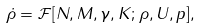<formula> <loc_0><loc_0><loc_500><loc_500>\dot { \rho } = \mathcal { F } [ N , M , \gamma , K ; \rho , U , p ] ,</formula> 